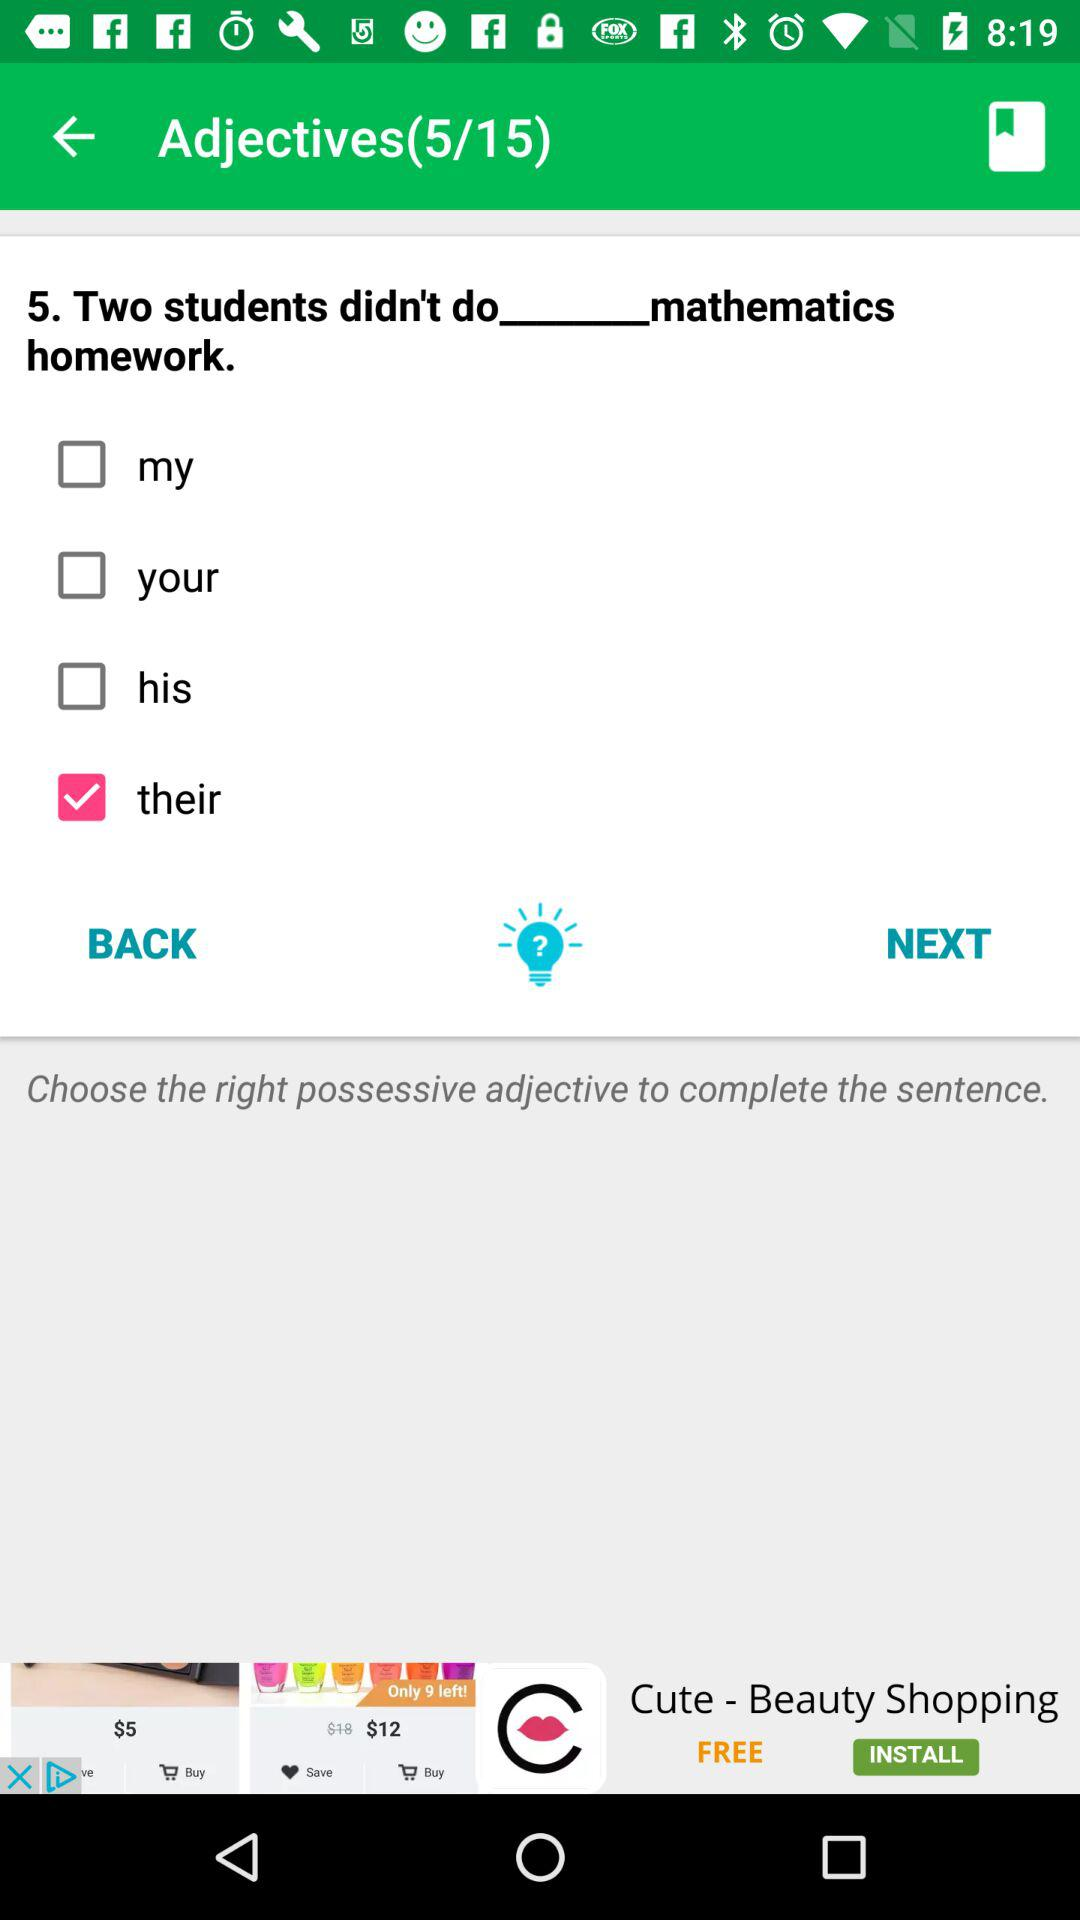Which option is checked? The checked option is "their". 